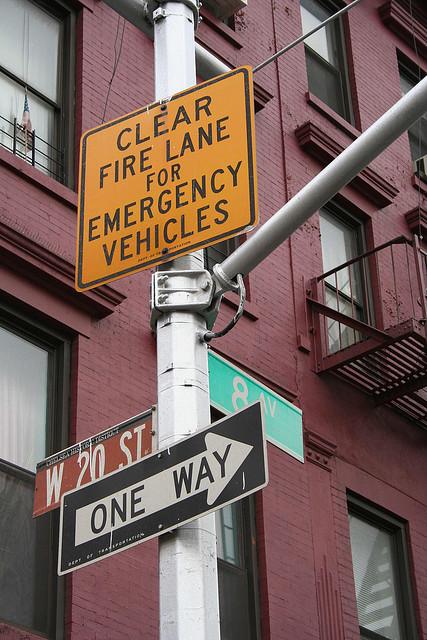What way is the bottom one way sign pointing?
Quick response, please. Right. What needs to be cleared for emergency vehicles?
Write a very short answer. Fire lane. How many "One Way" signs are there?
Give a very brief answer. 1. How many words are in the very top sign?
Concise answer only. 6. Is the street e 20 St?
Concise answer only. No. 